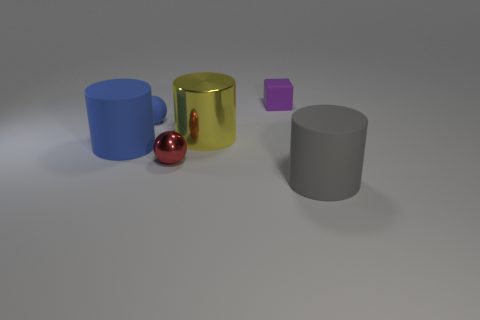Add 3 small gray cubes. How many objects exist? 9 Subtract all balls. How many objects are left? 4 Subtract 1 red balls. How many objects are left? 5 Subtract all big blue cylinders. Subtract all tiny blue spheres. How many objects are left? 4 Add 4 big rubber cylinders. How many big rubber cylinders are left? 6 Add 1 blue matte objects. How many blue matte objects exist? 3 